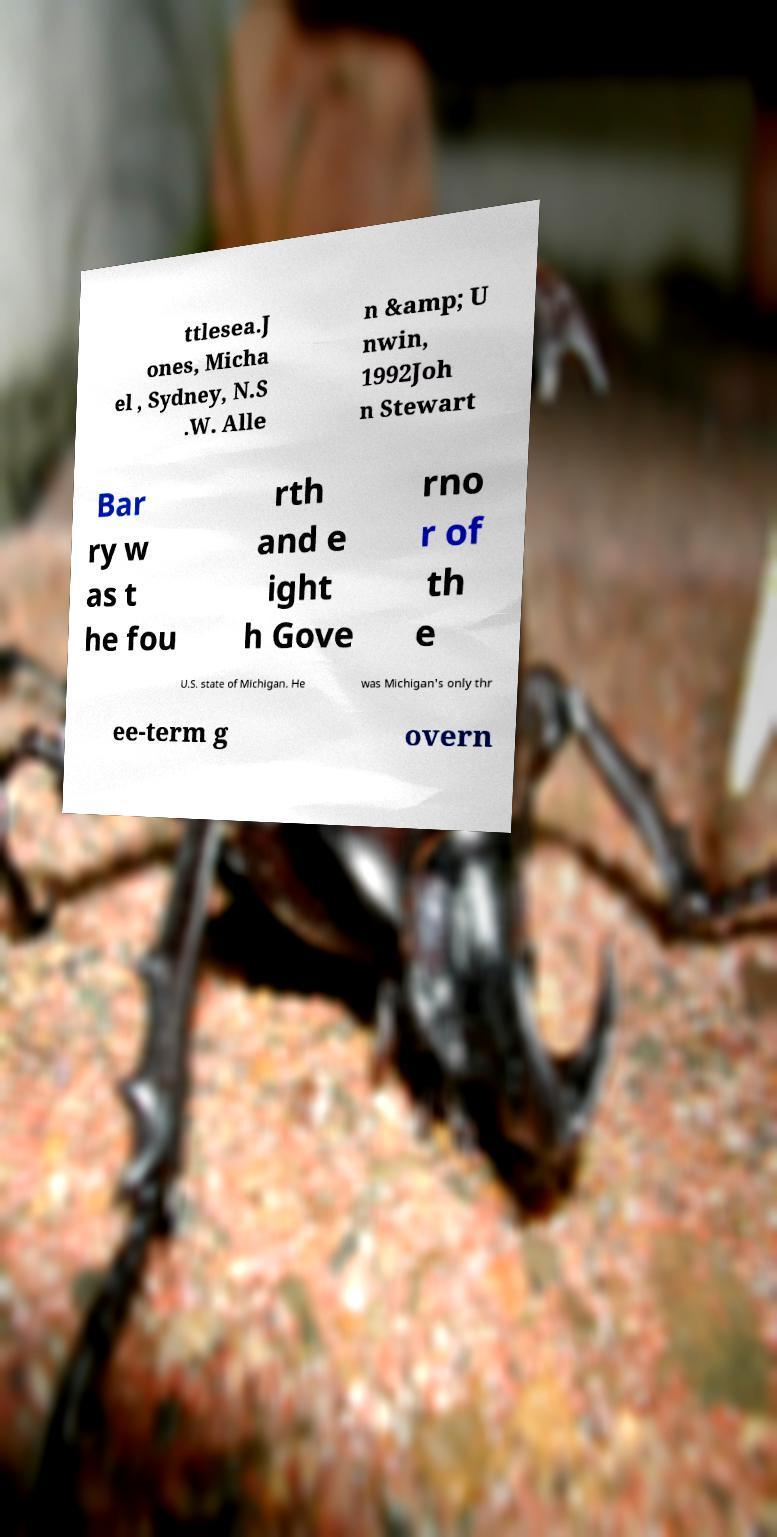For documentation purposes, I need the text within this image transcribed. Could you provide that? ttlesea.J ones, Micha el , Sydney, N.S .W. Alle n &amp; U nwin, 1992Joh n Stewart Bar ry w as t he fou rth and e ight h Gove rno r of th e U.S. state of Michigan. He was Michigan's only thr ee-term g overn 